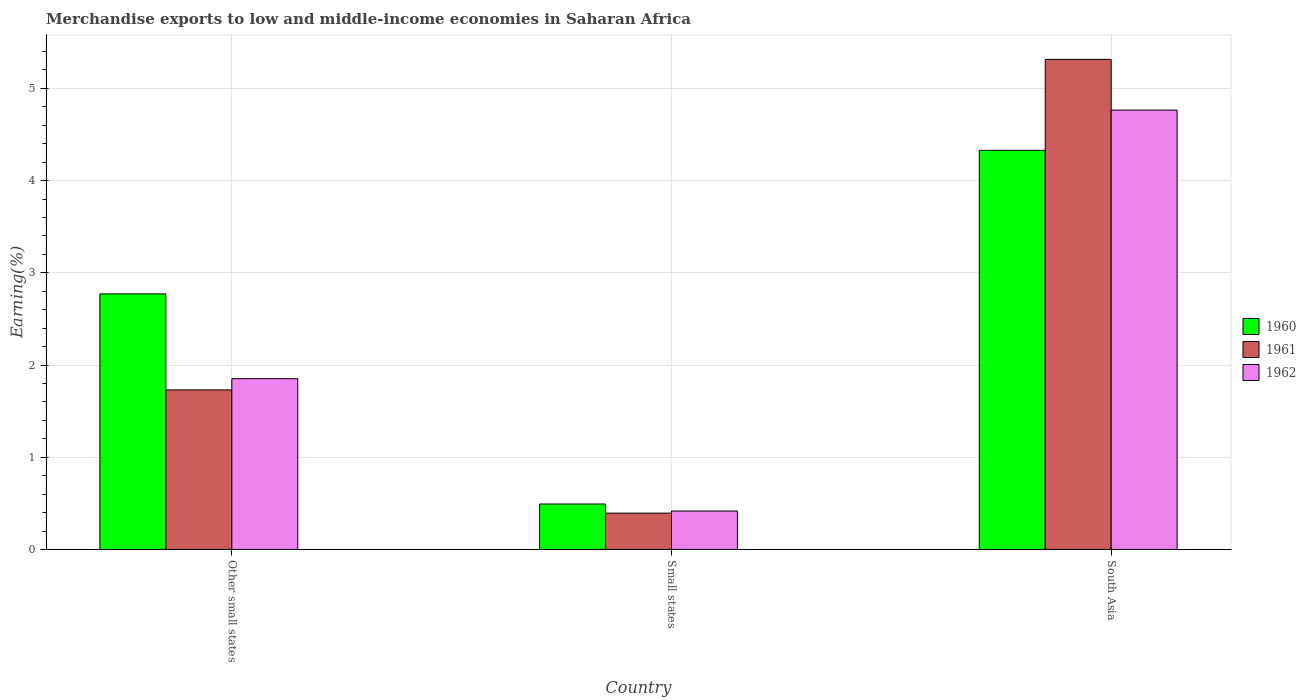How many different coloured bars are there?
Make the answer very short. 3. Are the number of bars per tick equal to the number of legend labels?
Ensure brevity in your answer.  Yes. How many bars are there on the 1st tick from the left?
Ensure brevity in your answer.  3. What is the label of the 2nd group of bars from the left?
Provide a short and direct response. Small states. What is the percentage of amount earned from merchandise exports in 1962 in Other small states?
Your response must be concise. 1.85. Across all countries, what is the maximum percentage of amount earned from merchandise exports in 1961?
Your answer should be very brief. 5.31. Across all countries, what is the minimum percentage of amount earned from merchandise exports in 1962?
Make the answer very short. 0.42. In which country was the percentage of amount earned from merchandise exports in 1960 minimum?
Ensure brevity in your answer.  Small states. What is the total percentage of amount earned from merchandise exports in 1962 in the graph?
Your answer should be very brief. 7.03. What is the difference between the percentage of amount earned from merchandise exports in 1961 in Small states and that in South Asia?
Give a very brief answer. -4.92. What is the difference between the percentage of amount earned from merchandise exports in 1962 in South Asia and the percentage of amount earned from merchandise exports in 1961 in Other small states?
Offer a very short reply. 3.03. What is the average percentage of amount earned from merchandise exports in 1960 per country?
Keep it short and to the point. 2.53. What is the difference between the percentage of amount earned from merchandise exports of/in 1962 and percentage of amount earned from merchandise exports of/in 1960 in Other small states?
Your answer should be very brief. -0.92. What is the ratio of the percentage of amount earned from merchandise exports in 1962 in Small states to that in South Asia?
Provide a succinct answer. 0.09. Is the percentage of amount earned from merchandise exports in 1962 in Other small states less than that in South Asia?
Your response must be concise. Yes. What is the difference between the highest and the second highest percentage of amount earned from merchandise exports in 1962?
Provide a succinct answer. -1.44. What is the difference between the highest and the lowest percentage of amount earned from merchandise exports in 1960?
Provide a succinct answer. 3.84. In how many countries, is the percentage of amount earned from merchandise exports in 1960 greater than the average percentage of amount earned from merchandise exports in 1960 taken over all countries?
Make the answer very short. 2. How many bars are there?
Provide a succinct answer. 9. Are all the bars in the graph horizontal?
Keep it short and to the point. No. What is the difference between two consecutive major ticks on the Y-axis?
Offer a terse response. 1. Are the values on the major ticks of Y-axis written in scientific E-notation?
Give a very brief answer. No. Where does the legend appear in the graph?
Provide a short and direct response. Center right. What is the title of the graph?
Keep it short and to the point. Merchandise exports to low and middle-income economies in Saharan Africa. What is the label or title of the X-axis?
Provide a short and direct response. Country. What is the label or title of the Y-axis?
Make the answer very short. Earning(%). What is the Earning(%) of 1960 in Other small states?
Make the answer very short. 2.77. What is the Earning(%) in 1961 in Other small states?
Keep it short and to the point. 1.73. What is the Earning(%) of 1962 in Other small states?
Provide a short and direct response. 1.85. What is the Earning(%) of 1960 in Small states?
Give a very brief answer. 0.49. What is the Earning(%) in 1961 in Small states?
Provide a succinct answer. 0.39. What is the Earning(%) in 1962 in Small states?
Give a very brief answer. 0.42. What is the Earning(%) in 1960 in South Asia?
Offer a terse response. 4.33. What is the Earning(%) of 1961 in South Asia?
Offer a very short reply. 5.31. What is the Earning(%) in 1962 in South Asia?
Provide a short and direct response. 4.76. Across all countries, what is the maximum Earning(%) in 1960?
Give a very brief answer. 4.33. Across all countries, what is the maximum Earning(%) in 1961?
Offer a terse response. 5.31. Across all countries, what is the maximum Earning(%) in 1962?
Your answer should be compact. 4.76. Across all countries, what is the minimum Earning(%) in 1960?
Make the answer very short. 0.49. Across all countries, what is the minimum Earning(%) of 1961?
Ensure brevity in your answer.  0.39. Across all countries, what is the minimum Earning(%) in 1962?
Your response must be concise. 0.42. What is the total Earning(%) of 1960 in the graph?
Your answer should be compact. 7.59. What is the total Earning(%) in 1961 in the graph?
Offer a very short reply. 7.44. What is the total Earning(%) of 1962 in the graph?
Your response must be concise. 7.03. What is the difference between the Earning(%) in 1960 in Other small states and that in Small states?
Ensure brevity in your answer.  2.28. What is the difference between the Earning(%) of 1961 in Other small states and that in Small states?
Ensure brevity in your answer.  1.34. What is the difference between the Earning(%) in 1962 in Other small states and that in Small states?
Provide a short and direct response. 1.44. What is the difference between the Earning(%) of 1960 in Other small states and that in South Asia?
Provide a short and direct response. -1.56. What is the difference between the Earning(%) in 1961 in Other small states and that in South Asia?
Make the answer very short. -3.58. What is the difference between the Earning(%) of 1962 in Other small states and that in South Asia?
Your answer should be very brief. -2.91. What is the difference between the Earning(%) of 1960 in Small states and that in South Asia?
Offer a very short reply. -3.84. What is the difference between the Earning(%) in 1961 in Small states and that in South Asia?
Ensure brevity in your answer.  -4.92. What is the difference between the Earning(%) in 1962 in Small states and that in South Asia?
Make the answer very short. -4.35. What is the difference between the Earning(%) in 1960 in Other small states and the Earning(%) in 1961 in Small states?
Give a very brief answer. 2.38. What is the difference between the Earning(%) of 1960 in Other small states and the Earning(%) of 1962 in Small states?
Give a very brief answer. 2.35. What is the difference between the Earning(%) of 1961 in Other small states and the Earning(%) of 1962 in Small states?
Ensure brevity in your answer.  1.31. What is the difference between the Earning(%) in 1960 in Other small states and the Earning(%) in 1961 in South Asia?
Offer a terse response. -2.54. What is the difference between the Earning(%) of 1960 in Other small states and the Earning(%) of 1962 in South Asia?
Provide a short and direct response. -1.99. What is the difference between the Earning(%) in 1961 in Other small states and the Earning(%) in 1962 in South Asia?
Your answer should be compact. -3.03. What is the difference between the Earning(%) of 1960 in Small states and the Earning(%) of 1961 in South Asia?
Offer a very short reply. -4.82. What is the difference between the Earning(%) of 1960 in Small states and the Earning(%) of 1962 in South Asia?
Your response must be concise. -4.27. What is the difference between the Earning(%) of 1961 in Small states and the Earning(%) of 1962 in South Asia?
Your answer should be compact. -4.37. What is the average Earning(%) in 1960 per country?
Your answer should be compact. 2.53. What is the average Earning(%) in 1961 per country?
Your answer should be very brief. 2.48. What is the average Earning(%) in 1962 per country?
Your answer should be very brief. 2.34. What is the difference between the Earning(%) in 1960 and Earning(%) in 1961 in Other small states?
Offer a very short reply. 1.04. What is the difference between the Earning(%) in 1960 and Earning(%) in 1962 in Other small states?
Offer a very short reply. 0.92. What is the difference between the Earning(%) of 1961 and Earning(%) of 1962 in Other small states?
Offer a very short reply. -0.12. What is the difference between the Earning(%) in 1960 and Earning(%) in 1961 in Small states?
Ensure brevity in your answer.  0.1. What is the difference between the Earning(%) in 1960 and Earning(%) in 1962 in Small states?
Keep it short and to the point. 0.08. What is the difference between the Earning(%) in 1961 and Earning(%) in 1962 in Small states?
Make the answer very short. -0.02. What is the difference between the Earning(%) in 1960 and Earning(%) in 1961 in South Asia?
Offer a very short reply. -0.99. What is the difference between the Earning(%) of 1960 and Earning(%) of 1962 in South Asia?
Your answer should be very brief. -0.44. What is the difference between the Earning(%) of 1961 and Earning(%) of 1962 in South Asia?
Make the answer very short. 0.55. What is the ratio of the Earning(%) of 1960 in Other small states to that in Small states?
Ensure brevity in your answer.  5.62. What is the ratio of the Earning(%) of 1961 in Other small states to that in Small states?
Give a very brief answer. 4.39. What is the ratio of the Earning(%) of 1962 in Other small states to that in Small states?
Provide a short and direct response. 4.44. What is the ratio of the Earning(%) in 1960 in Other small states to that in South Asia?
Offer a terse response. 0.64. What is the ratio of the Earning(%) of 1961 in Other small states to that in South Asia?
Give a very brief answer. 0.33. What is the ratio of the Earning(%) of 1962 in Other small states to that in South Asia?
Your answer should be compact. 0.39. What is the ratio of the Earning(%) in 1960 in Small states to that in South Asia?
Your answer should be compact. 0.11. What is the ratio of the Earning(%) of 1961 in Small states to that in South Asia?
Make the answer very short. 0.07. What is the ratio of the Earning(%) in 1962 in Small states to that in South Asia?
Offer a very short reply. 0.09. What is the difference between the highest and the second highest Earning(%) in 1960?
Make the answer very short. 1.56. What is the difference between the highest and the second highest Earning(%) of 1961?
Your answer should be compact. 3.58. What is the difference between the highest and the second highest Earning(%) in 1962?
Your answer should be compact. 2.91. What is the difference between the highest and the lowest Earning(%) of 1960?
Ensure brevity in your answer.  3.84. What is the difference between the highest and the lowest Earning(%) of 1961?
Make the answer very short. 4.92. What is the difference between the highest and the lowest Earning(%) of 1962?
Provide a short and direct response. 4.35. 